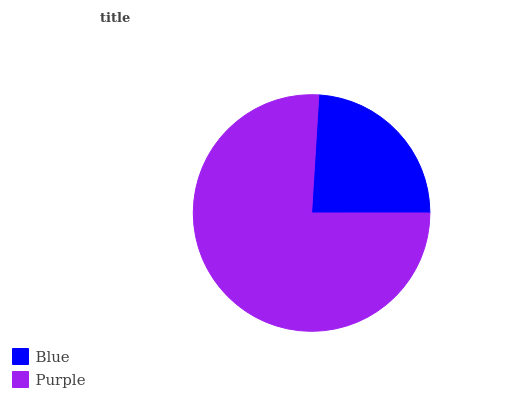Is Blue the minimum?
Answer yes or no. Yes. Is Purple the maximum?
Answer yes or no. Yes. Is Purple the minimum?
Answer yes or no. No. Is Purple greater than Blue?
Answer yes or no. Yes. Is Blue less than Purple?
Answer yes or no. Yes. Is Blue greater than Purple?
Answer yes or no. No. Is Purple less than Blue?
Answer yes or no. No. Is Purple the high median?
Answer yes or no. Yes. Is Blue the low median?
Answer yes or no. Yes. Is Blue the high median?
Answer yes or no. No. Is Purple the low median?
Answer yes or no. No. 